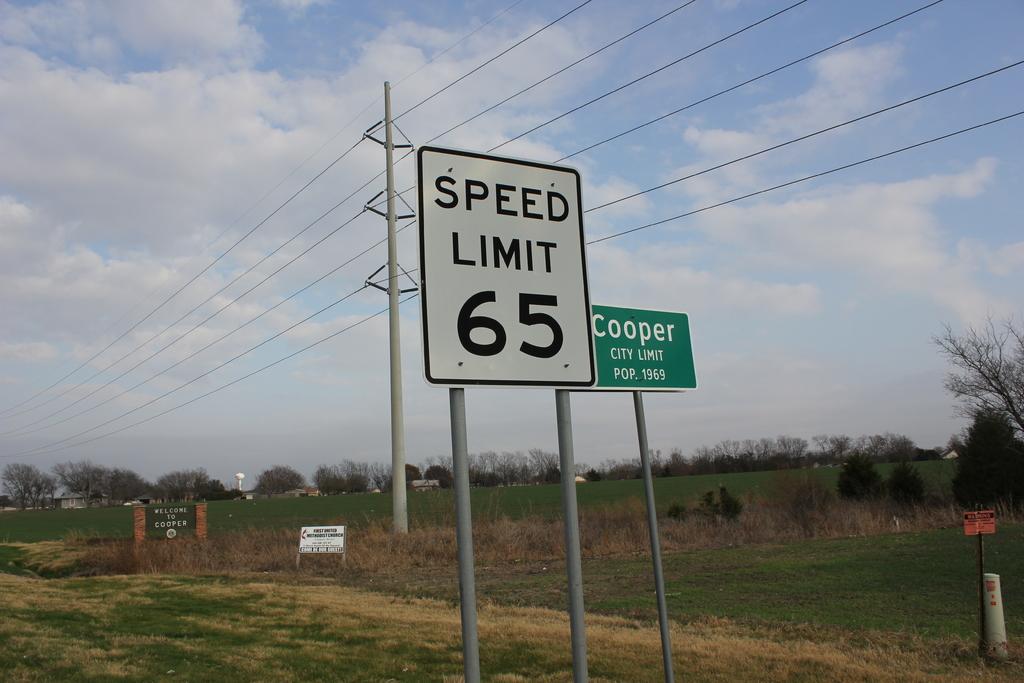What's the speed limit?
Ensure brevity in your answer.  65. What city are we about to enter?
Provide a short and direct response. Cooper. 